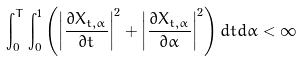Convert formula to latex. <formula><loc_0><loc_0><loc_500><loc_500>\int _ { 0 } ^ { T } \int _ { 0 } ^ { 1 } \left ( \left | \frac { \partial X _ { t , \alpha } } { \partial t } \right | ^ { 2 } + \left | \frac { \partial X _ { t , \alpha } } { \partial \alpha } \right | ^ { 2 } \right ) d t d \alpha < \infty</formula> 